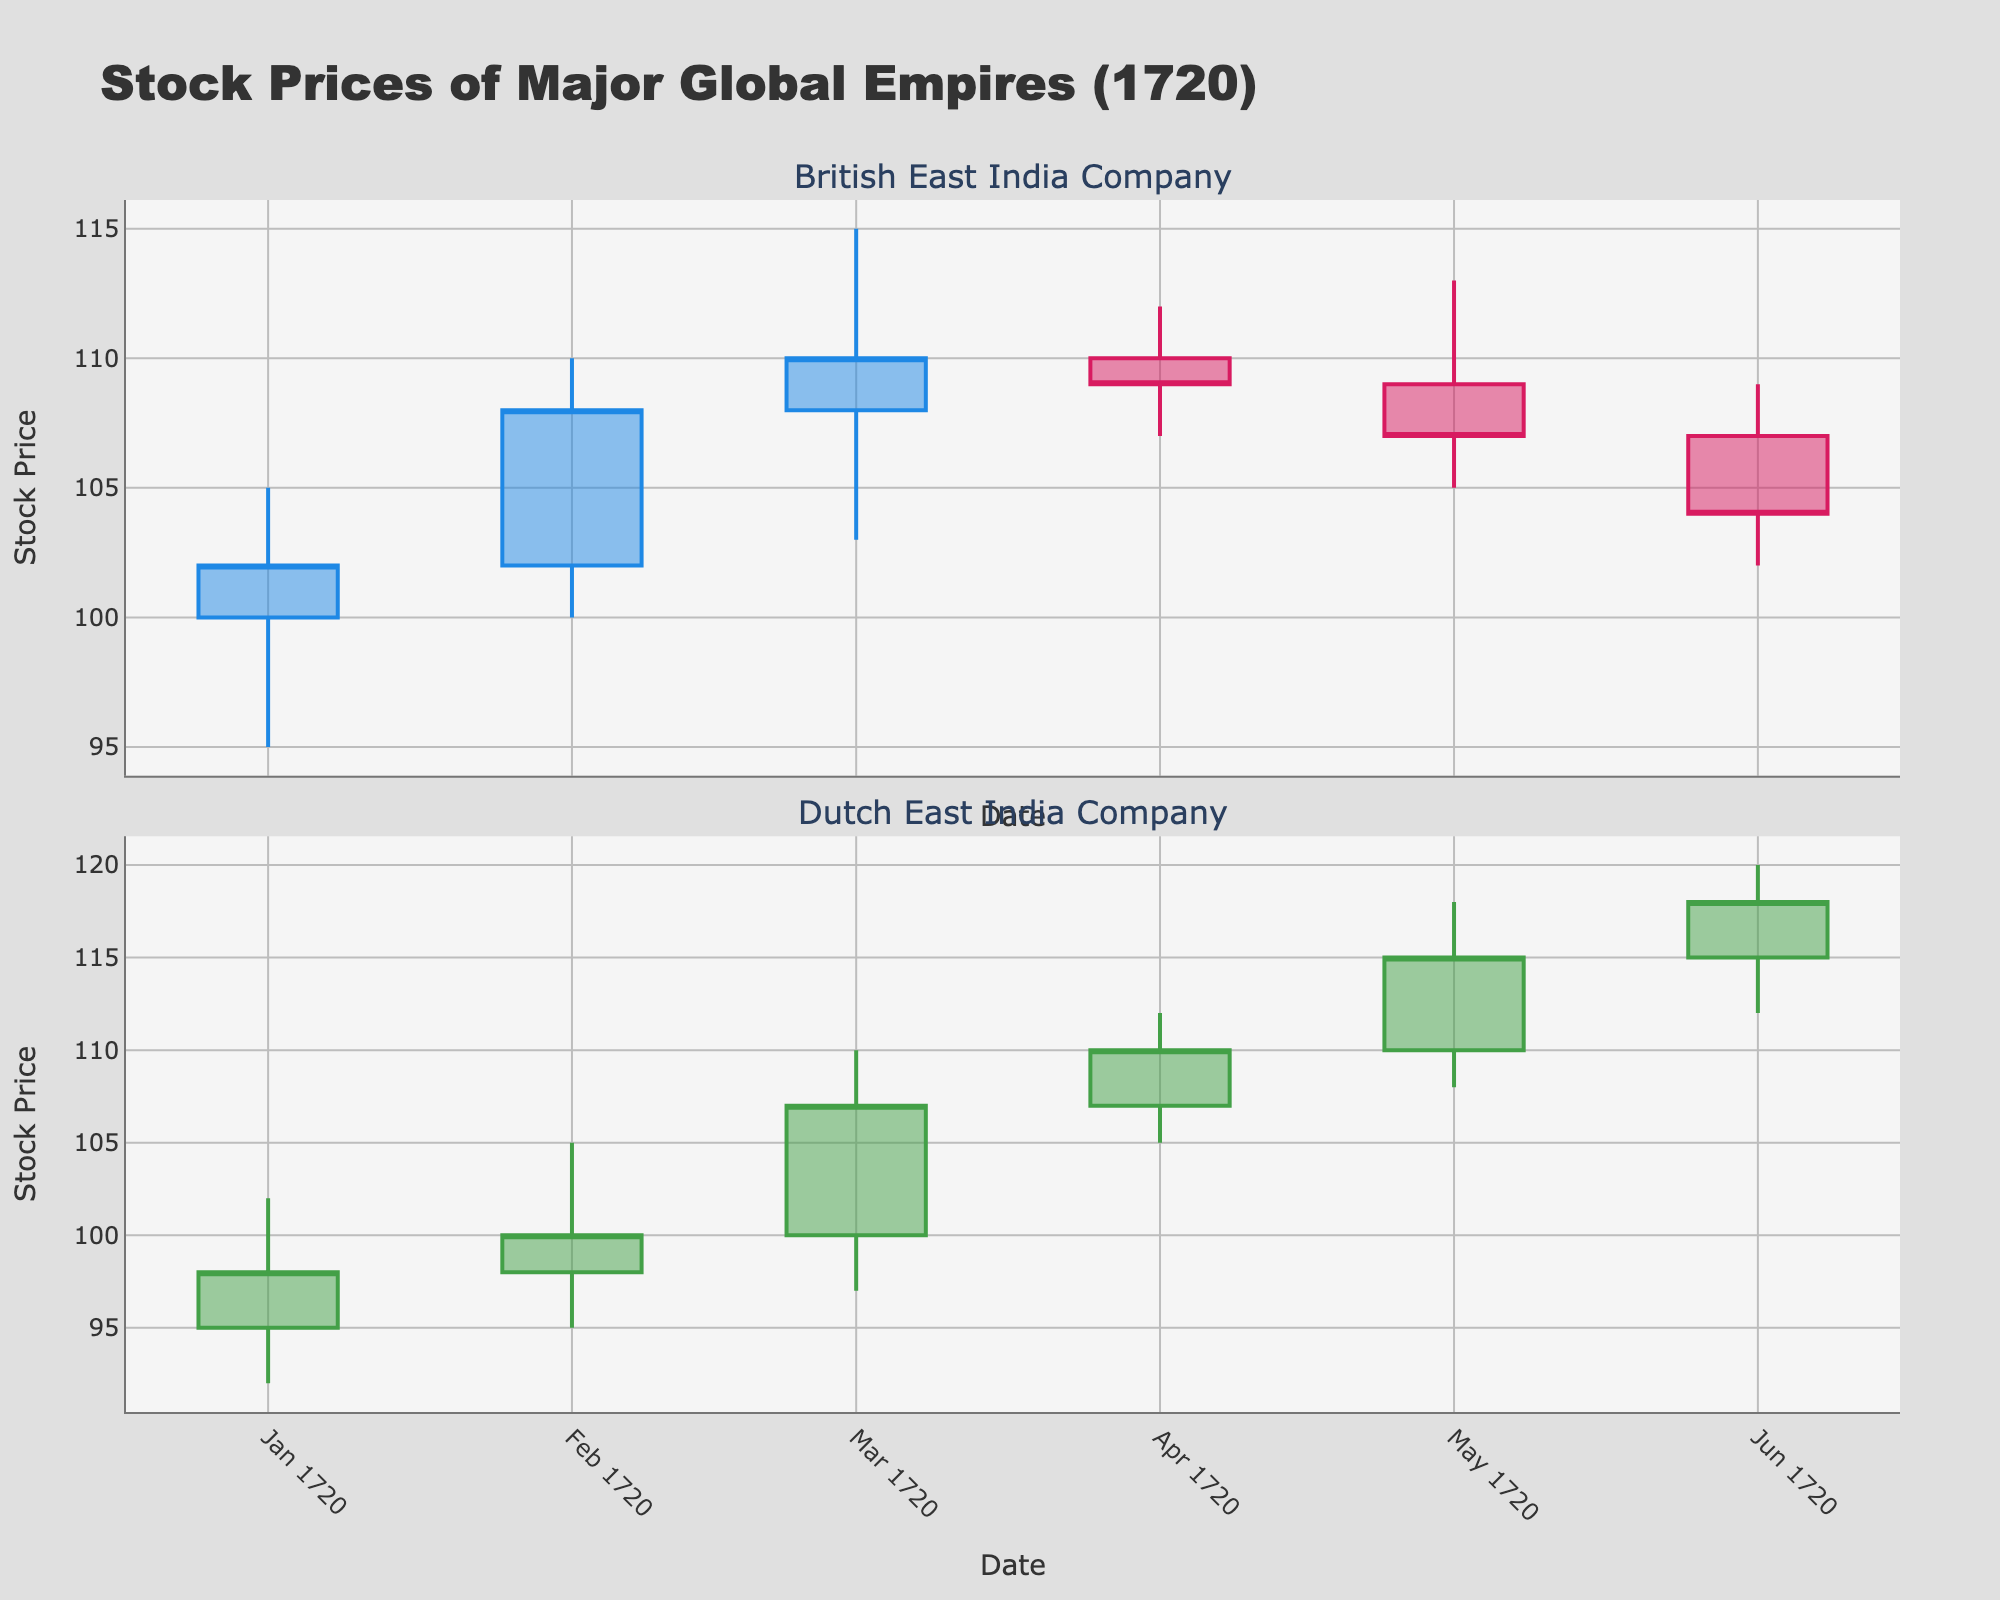What are the highest and lowest stock prices for the British East India Company in April 1720? Look at the British East India Company's candlestick for April 1720; the highest stock price is the top of the upper shadow and the lowest stock price is the bottom of the lower shadow.
Answer: Highest: 112, Lowest: 107 What was the closing price of the Dutch East India Company in March 1720? Locate the candlestick for March 1720 for the Dutch East India Company; the closing price is the top of the body as it is a bearish candlestick (closed lower than it opened).
Answer: 107 Which entity had a higher closing price in June 1720? Compare the closing prices for both companies in June 1720; read the values at the top or bottom of the candlesticks depending on the color (bearish or bullish).
Answer: Dutch East India Company Looking at the Dutch East India Company, which month had the greatest increase in stock price from open to close? For each candlestick of the Dutch East India Company, calculate the difference between open and close prices, then identify the month with the highest increase.
Answer: May 1720 How many months did the British East India Company experience a decrease in its closing stock price? Count the number of red candlesticks for the British East India Company, as they represent a decrease (close < open).
Answer: 3 Between February and March 1720, which company showed a greater price fluctuation in terms of high and low values? Calculate the price range (high - low) for both companies in February and March 1720 and compare them.
Answer: Dutch East India Company What is the average closing price for the British East India Company across the six months displayed? Sum the closing prices for the British East India Company across the six months and divide by the number of months. Calculation: (102 + 108 + 110 + 109 + 107 + 104) / 6.
Answer: 106.67 